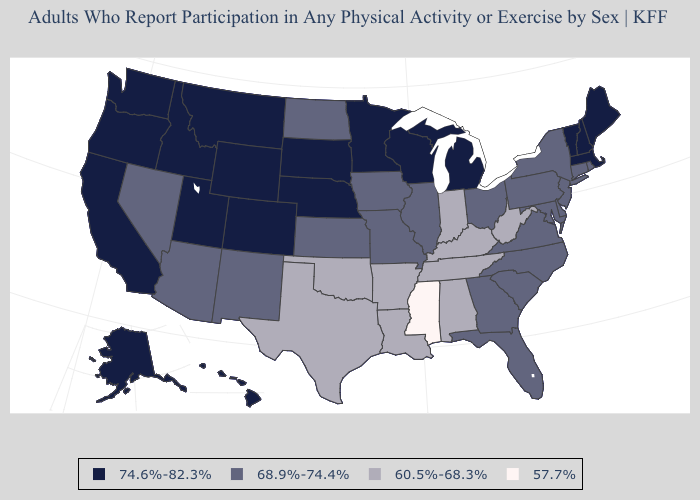What is the lowest value in states that border Maine?
Quick response, please. 74.6%-82.3%. Name the states that have a value in the range 68.9%-74.4%?
Be succinct. Arizona, Connecticut, Delaware, Florida, Georgia, Illinois, Iowa, Kansas, Maryland, Missouri, Nevada, New Jersey, New Mexico, New York, North Carolina, North Dakota, Ohio, Pennsylvania, Rhode Island, South Carolina, Virginia. Is the legend a continuous bar?
Give a very brief answer. No. Name the states that have a value in the range 74.6%-82.3%?
Give a very brief answer. Alaska, California, Colorado, Hawaii, Idaho, Maine, Massachusetts, Michigan, Minnesota, Montana, Nebraska, New Hampshire, Oregon, South Dakota, Utah, Vermont, Washington, Wisconsin, Wyoming. Does Mississippi have the lowest value in the South?
Be succinct. Yes. Name the states that have a value in the range 74.6%-82.3%?
Give a very brief answer. Alaska, California, Colorado, Hawaii, Idaho, Maine, Massachusetts, Michigan, Minnesota, Montana, Nebraska, New Hampshire, Oregon, South Dakota, Utah, Vermont, Washington, Wisconsin, Wyoming. What is the highest value in the Northeast ?
Be succinct. 74.6%-82.3%. What is the value of Maine?
Give a very brief answer. 74.6%-82.3%. Does Mississippi have the lowest value in the USA?
Quick response, please. Yes. Does Idaho have the highest value in the West?
Answer briefly. Yes. What is the value of Massachusetts?
Give a very brief answer. 74.6%-82.3%. What is the value of California?
Give a very brief answer. 74.6%-82.3%. What is the value of North Carolina?
Write a very short answer. 68.9%-74.4%. Does Wisconsin have the same value as New Jersey?
Short answer required. No. Among the states that border Oregon , which have the lowest value?
Short answer required. Nevada. 